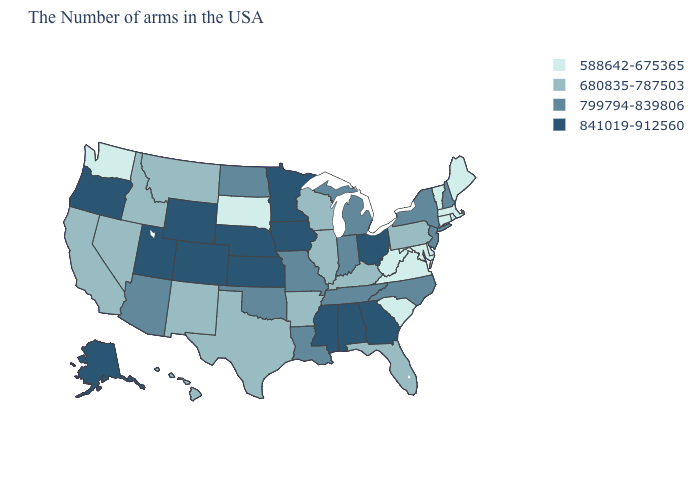Name the states that have a value in the range 680835-787503?
Answer briefly. Pennsylvania, Florida, Kentucky, Wisconsin, Illinois, Arkansas, Texas, New Mexico, Montana, Idaho, Nevada, California, Hawaii. Which states have the lowest value in the West?
Keep it brief. Washington. What is the value of Ohio?
Short answer required. 841019-912560. Among the states that border Wyoming , which have the highest value?
Short answer required. Nebraska, Colorado, Utah. Which states hav the highest value in the MidWest?
Be succinct. Ohio, Minnesota, Iowa, Kansas, Nebraska. What is the value of New Jersey?
Keep it brief. 799794-839806. What is the lowest value in states that border Louisiana?
Short answer required. 680835-787503. Name the states that have a value in the range 799794-839806?
Write a very short answer. New Hampshire, New York, New Jersey, North Carolina, Michigan, Indiana, Tennessee, Louisiana, Missouri, Oklahoma, North Dakota, Arizona. What is the value of Massachusetts?
Be succinct. 588642-675365. Does Vermont have the highest value in the Northeast?
Keep it brief. No. Which states have the lowest value in the USA?
Write a very short answer. Maine, Massachusetts, Rhode Island, Vermont, Connecticut, Delaware, Maryland, Virginia, South Carolina, West Virginia, South Dakota, Washington. What is the value of Rhode Island?
Keep it brief. 588642-675365. Name the states that have a value in the range 799794-839806?
Short answer required. New Hampshire, New York, New Jersey, North Carolina, Michigan, Indiana, Tennessee, Louisiana, Missouri, Oklahoma, North Dakota, Arizona. Name the states that have a value in the range 799794-839806?
Quick response, please. New Hampshire, New York, New Jersey, North Carolina, Michigan, Indiana, Tennessee, Louisiana, Missouri, Oklahoma, North Dakota, Arizona. Which states hav the highest value in the Northeast?
Write a very short answer. New Hampshire, New York, New Jersey. 